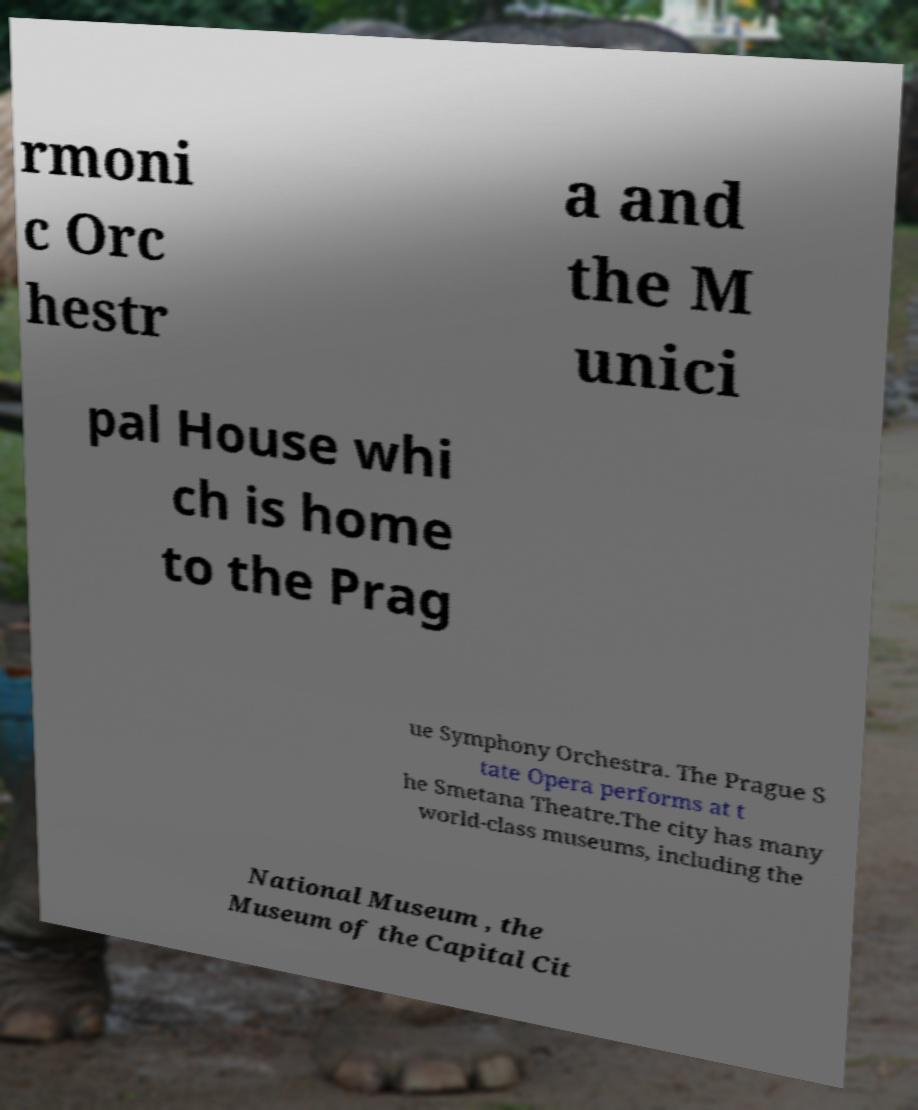What messages or text are displayed in this image? I need them in a readable, typed format. rmoni c Orc hestr a and the M unici pal House whi ch is home to the Prag ue Symphony Orchestra. The Prague S tate Opera performs at t he Smetana Theatre.The city has many world-class museums, including the National Museum , the Museum of the Capital Cit 